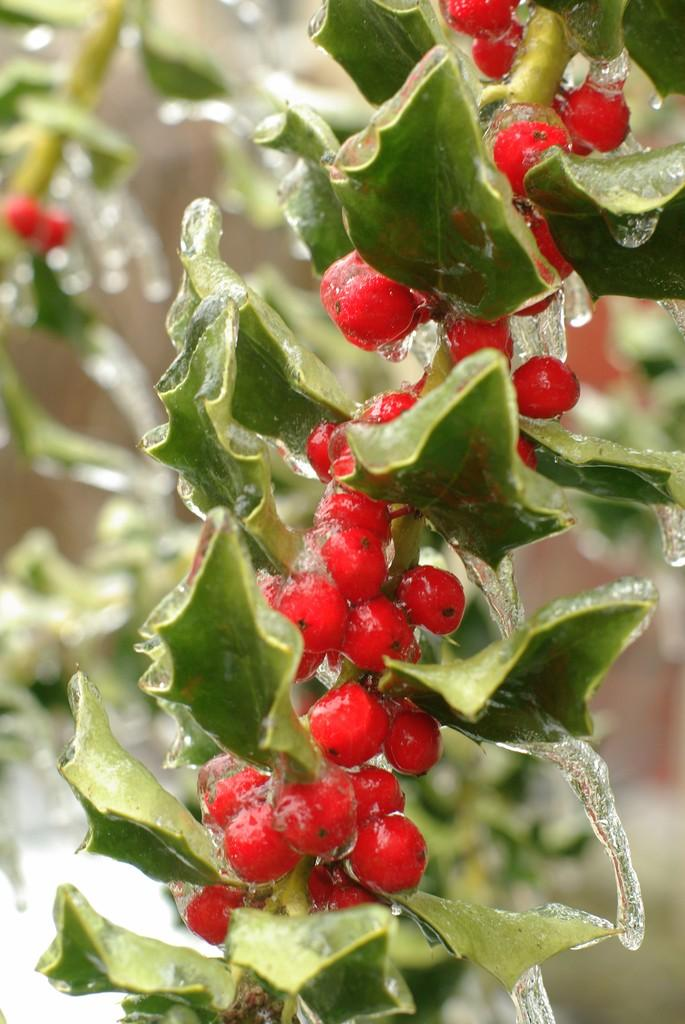What type of food can be seen in the image? There are fruits in the image. What color are the fruits? The fruits are red in color. What else is present in the image besides the fruits? There are leaves in the image. What color are the leaves? The leaves are green in color. What type of crack can be seen in the image? There is no crack present in the image; it features red fruits and green leaves. Is there a sail visible in the image? No, there is no sail present in the image. 